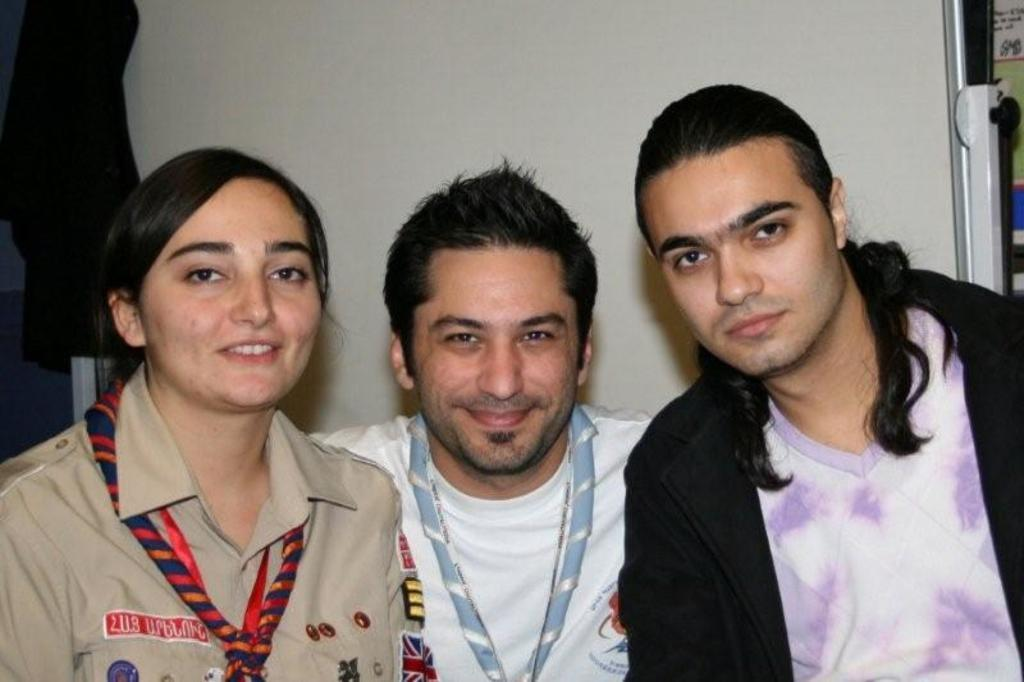Who or what can be seen in the image? There are people in the image. Can you describe the background or setting of the image? There are objects behind the people in the image. What type of paper is being used by the people in the image? There is no paper visible in the image; only people and objects behind them can be seen. 